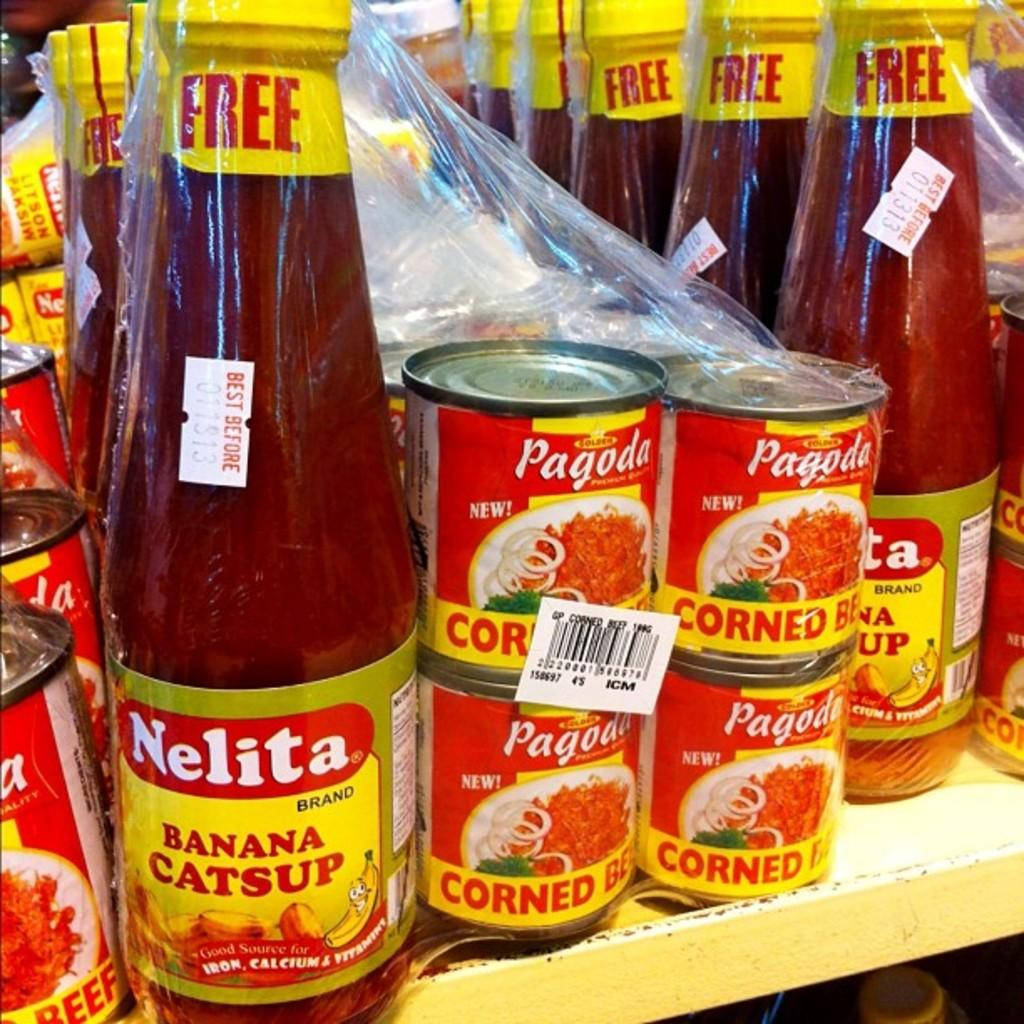<image>
Create a compact narrative representing the image presented. A bottle of Nelita brand Banana Catsup say free on the label. 